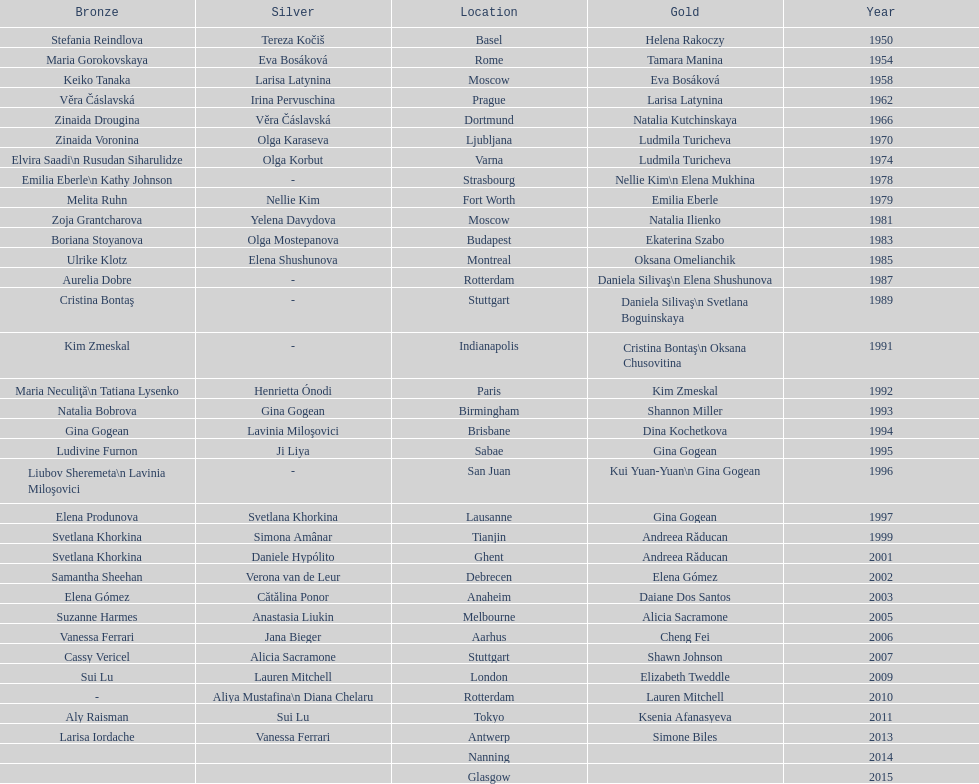As of 2013, what is the total number of floor exercise gold medals won by american women at the world championships? 5. 